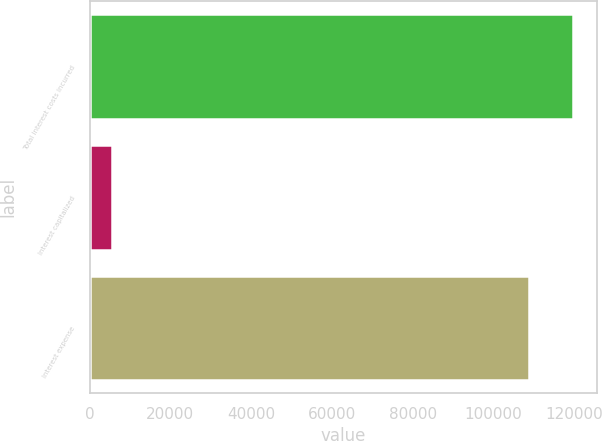<chart> <loc_0><loc_0><loc_500><loc_500><bar_chart><fcel>Total interest costs incurred<fcel>Interest capitalized<fcel>Interest expense<nl><fcel>119659<fcel>5549<fcel>108781<nl></chart> 